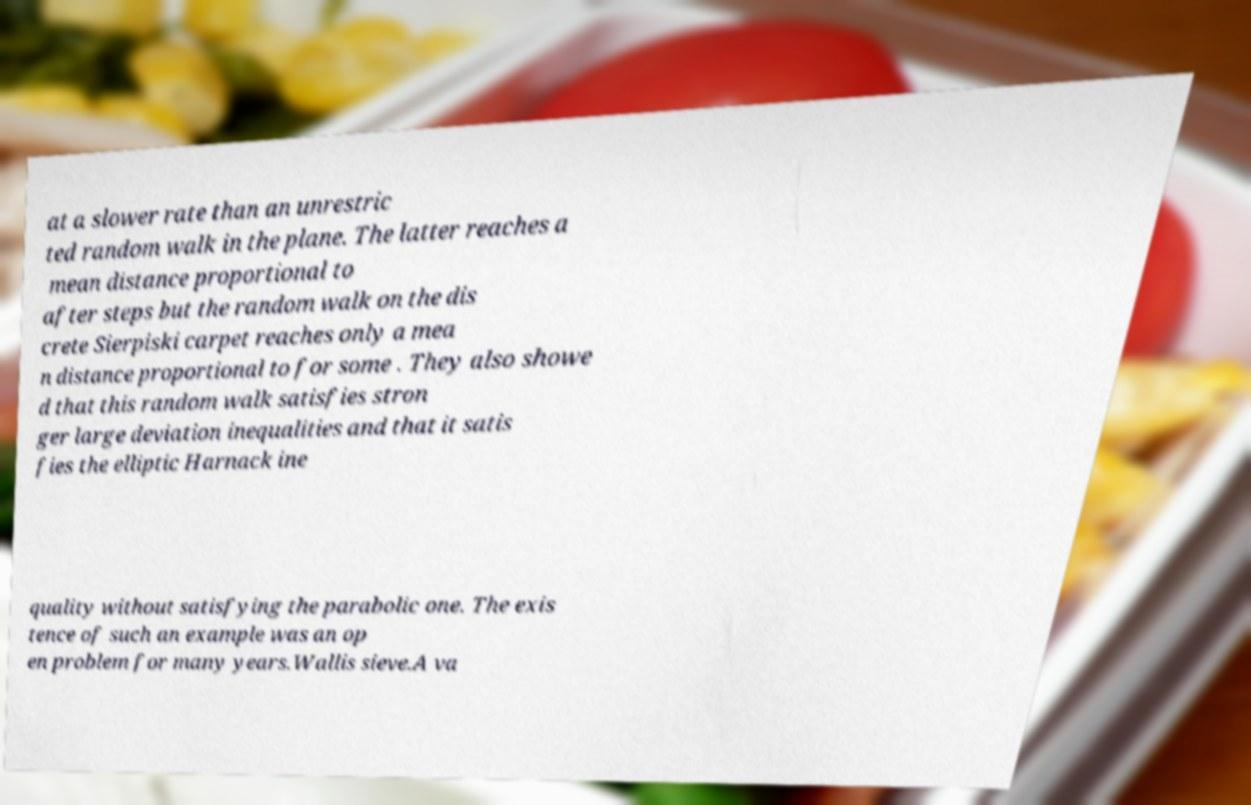What messages or text are displayed in this image? I need them in a readable, typed format. at a slower rate than an unrestric ted random walk in the plane. The latter reaches a mean distance proportional to after steps but the random walk on the dis crete Sierpiski carpet reaches only a mea n distance proportional to for some . They also showe d that this random walk satisfies stron ger large deviation inequalities and that it satis fies the elliptic Harnack ine quality without satisfying the parabolic one. The exis tence of such an example was an op en problem for many years.Wallis sieve.A va 